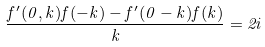Convert formula to latex. <formula><loc_0><loc_0><loc_500><loc_500>\frac { f ^ { \prime } ( 0 , k ) f ( - k ) - f ^ { \prime } ( 0 - k ) f ( k ) } { k } = 2 i</formula> 